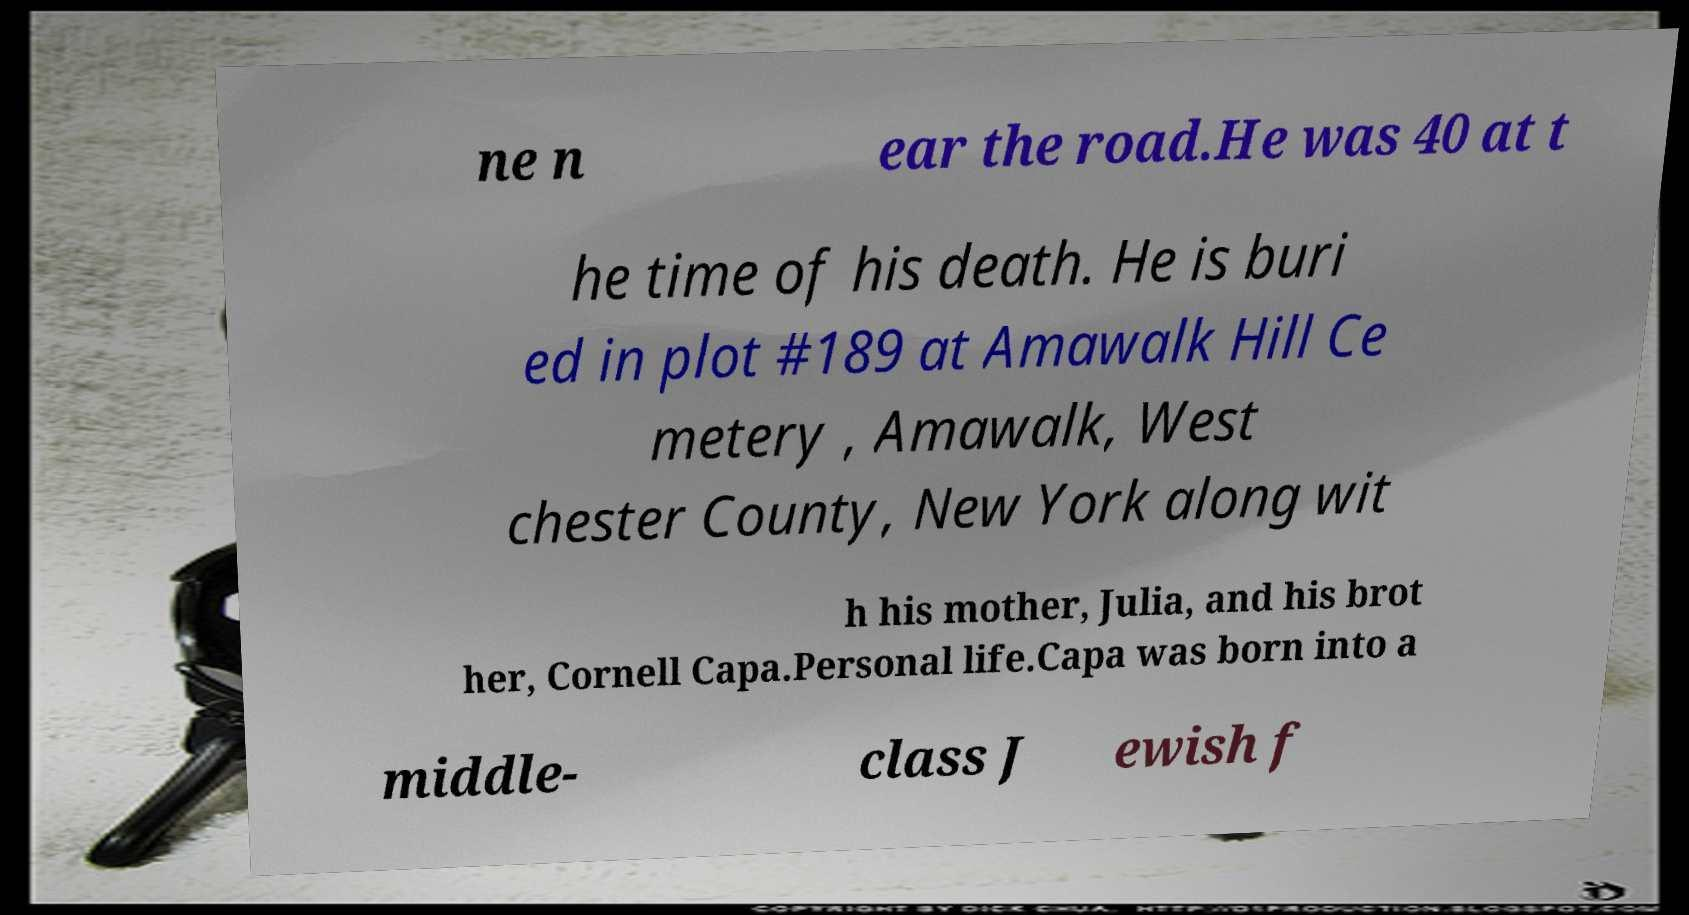Can you accurately transcribe the text from the provided image for me? ne n ear the road.He was 40 at t he time of his death. He is buri ed in plot #189 at Amawalk Hill Ce metery , Amawalk, West chester County, New York along wit h his mother, Julia, and his brot her, Cornell Capa.Personal life.Capa was born into a middle- class J ewish f 